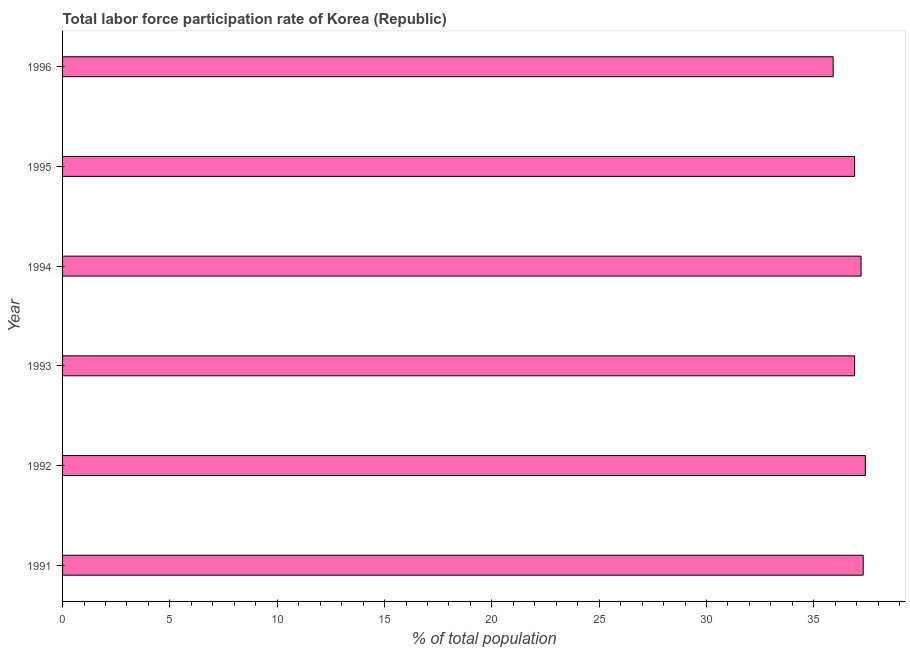What is the title of the graph?
Ensure brevity in your answer.  Total labor force participation rate of Korea (Republic). What is the label or title of the X-axis?
Your answer should be compact. % of total population. What is the total labor force participation rate in 1996?
Your answer should be very brief. 35.9. Across all years, what is the maximum total labor force participation rate?
Give a very brief answer. 37.4. Across all years, what is the minimum total labor force participation rate?
Make the answer very short. 35.9. What is the sum of the total labor force participation rate?
Give a very brief answer. 221.6. What is the average total labor force participation rate per year?
Your answer should be very brief. 36.93. What is the median total labor force participation rate?
Your response must be concise. 37.05. In how many years, is the total labor force participation rate greater than 10 %?
Provide a succinct answer. 6. Do a majority of the years between 1993 and 1992 (inclusive) have total labor force participation rate greater than 37 %?
Ensure brevity in your answer.  No. What is the ratio of the total labor force participation rate in 1994 to that in 1995?
Ensure brevity in your answer.  1.01. Is the total labor force participation rate in 1991 less than that in 1996?
Ensure brevity in your answer.  No. How many years are there in the graph?
Keep it short and to the point. 6. Are the values on the major ticks of X-axis written in scientific E-notation?
Your answer should be very brief. No. What is the % of total population in 1991?
Your response must be concise. 37.3. What is the % of total population of 1992?
Your answer should be very brief. 37.4. What is the % of total population in 1993?
Your response must be concise. 36.9. What is the % of total population of 1994?
Provide a short and direct response. 37.2. What is the % of total population of 1995?
Your answer should be compact. 36.9. What is the % of total population in 1996?
Ensure brevity in your answer.  35.9. What is the difference between the % of total population in 1992 and 1995?
Provide a short and direct response. 0.5. What is the difference between the % of total population in 1993 and 1994?
Your response must be concise. -0.3. What is the difference between the % of total population in 1993 and 1996?
Provide a short and direct response. 1. What is the difference between the % of total population in 1995 and 1996?
Your answer should be compact. 1. What is the ratio of the % of total population in 1991 to that in 1993?
Make the answer very short. 1.01. What is the ratio of the % of total population in 1991 to that in 1995?
Make the answer very short. 1.01. What is the ratio of the % of total population in 1991 to that in 1996?
Offer a very short reply. 1.04. What is the ratio of the % of total population in 1992 to that in 1995?
Provide a short and direct response. 1.01. What is the ratio of the % of total population in 1992 to that in 1996?
Give a very brief answer. 1.04. What is the ratio of the % of total population in 1993 to that in 1996?
Provide a succinct answer. 1.03. What is the ratio of the % of total population in 1994 to that in 1996?
Your answer should be compact. 1.04. What is the ratio of the % of total population in 1995 to that in 1996?
Your answer should be very brief. 1.03. 